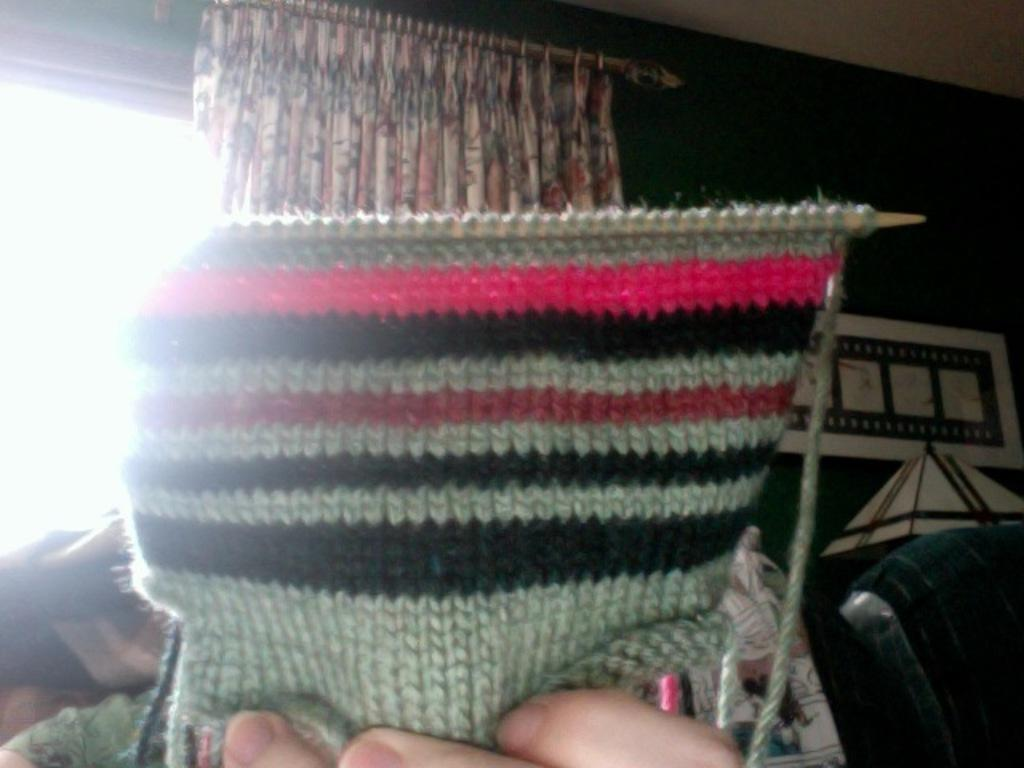What is the person in the image doing? The person is knitting wool. What can be seen in the background of the image? There is a curtain near a window, a table, and a wall hanging attached to the wall in the background. What type of waves can be seen crashing against the shore in the image? There are no waves or shore visible in the image; it features a person knitting wool with various background elements. 